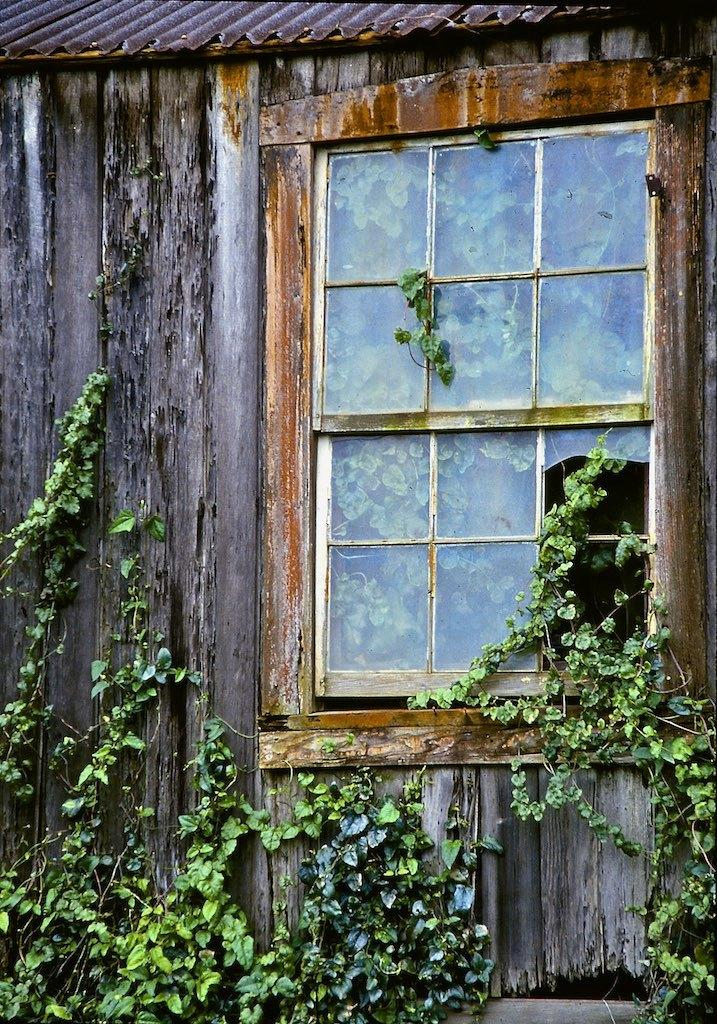What type of material is used for the wall in the image? There is a wooden wall in the image. What else can be seen in the image besides the wall? There are plants in the image. Where is the window located in the image? The window is on the right side of the image. How many tomatoes are hanging from the wooden wall in the image? There are no tomatoes present in the image; it only features a wooden wall and plants. What type of rod is used to support the plants in the image? There is no rod visible in the image; the plants are supported by the wooden wall. 